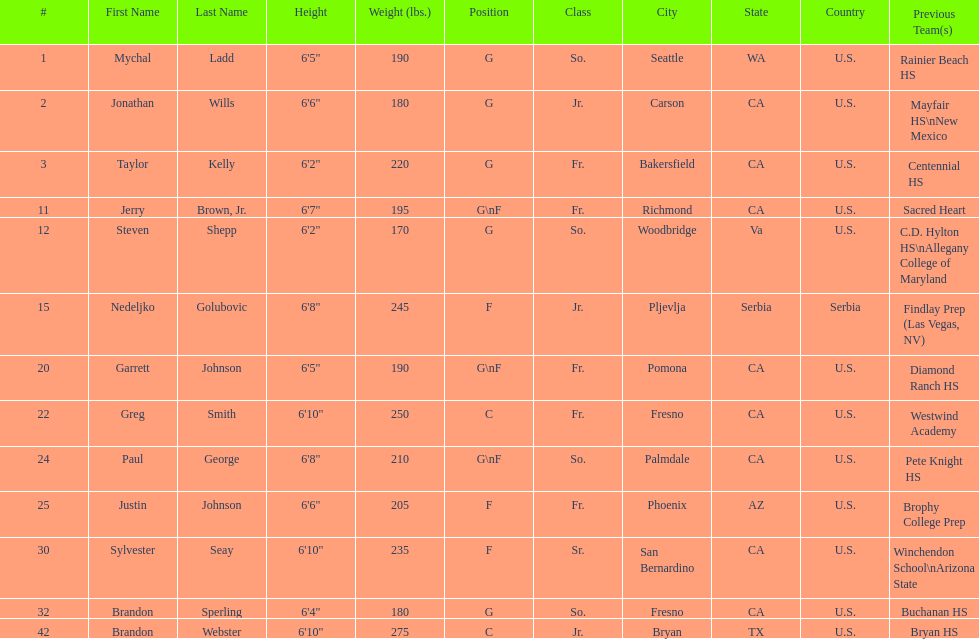Taylor kelly is shorter than 6' 3", which other player is also shorter than 6' 3"? Steven Shepp. 